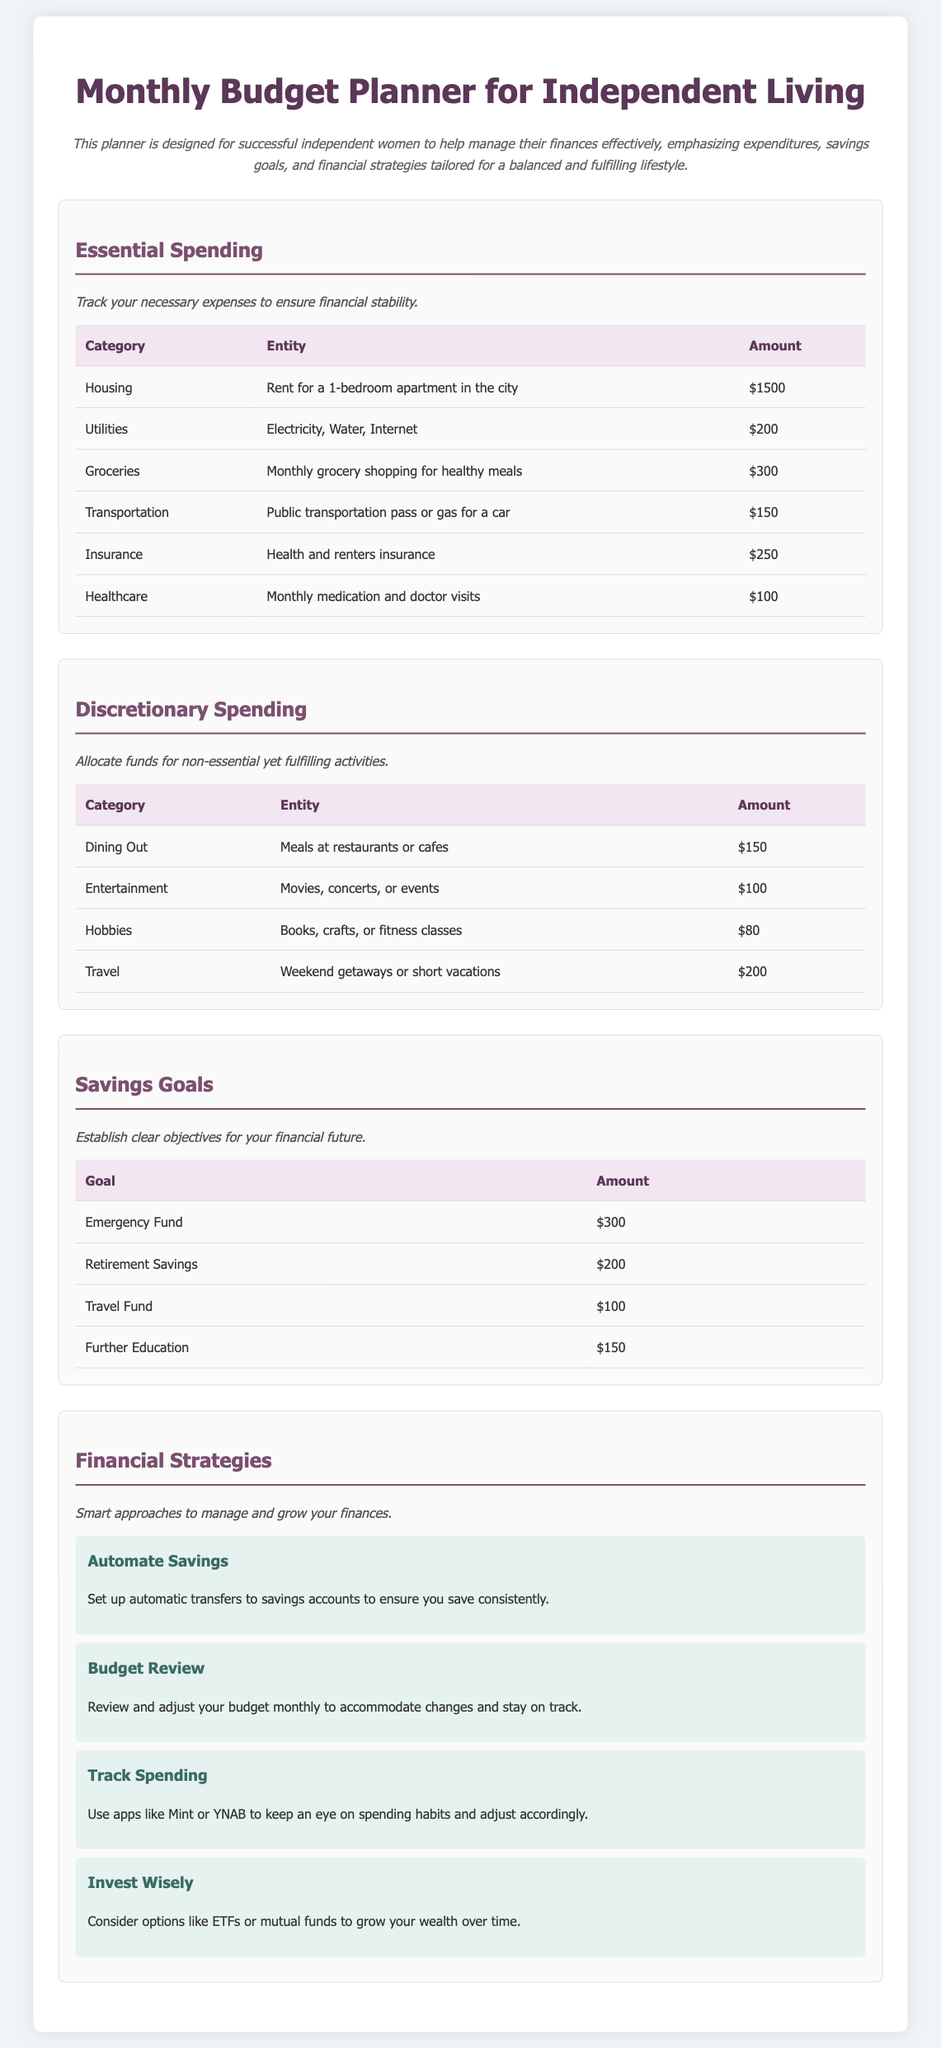What is the total amount allocated for essential spending? The total amount for essential spending is the sum of all the listed essential expenses in the table, which includes housing, utilities, groceries, transportation, insurance, and healthcare.
Answer: $2700 How much is allocated for groceries each month? The document explicitly lists the amount set aside for groceries in the Essential Spending section.
Answer: $300 What is the budget for entertainment? The document provides a specific amount for entertainment in the Discretionary Spending section.
Answer: $100 Which category has the highest spending in essential expenses? The examination of each essential spending category reveals which one has the highest amount allocated.
Answer: Housing What is the combined total for savings goals? The total for savings goals includes the sums of all listed savings goals in the appropriate section of the document.
Answer: $750 What strategy is suggested for tracking spending? The Financial Strategies section lists specific approaches, one of which is related to tracking spending habits.
Answer: Use apps like Mint or YNAB How many categories are listed under discretionary spending? The total number of categories can be determined by counting the entries in the Discretionary Spending section.
Answer: 4 What is the amount set aside for further education? The document provides a specific savings goal for further education under the Savings Goals section.
Answer: $150 Which financial strategy encourages review and adjustment? The Financial Strategies section specifically mentions this practice as a strategy for maintaining financial health.
Answer: Budget Review 